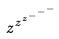<formula> <loc_0><loc_0><loc_500><loc_500>z ^ { z ^ { z ^ { - ^ { - ^ { - } } } } }</formula> 